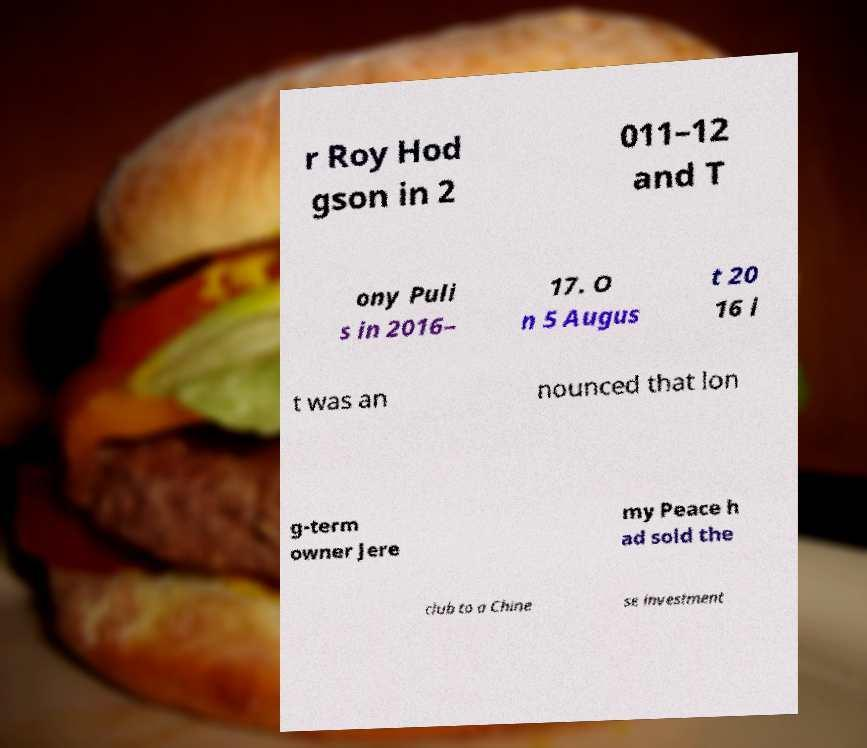Could you extract and type out the text from this image? r Roy Hod gson in 2 011–12 and T ony Puli s in 2016– 17. O n 5 Augus t 20 16 i t was an nounced that lon g-term owner Jere my Peace h ad sold the club to a Chine se investment 